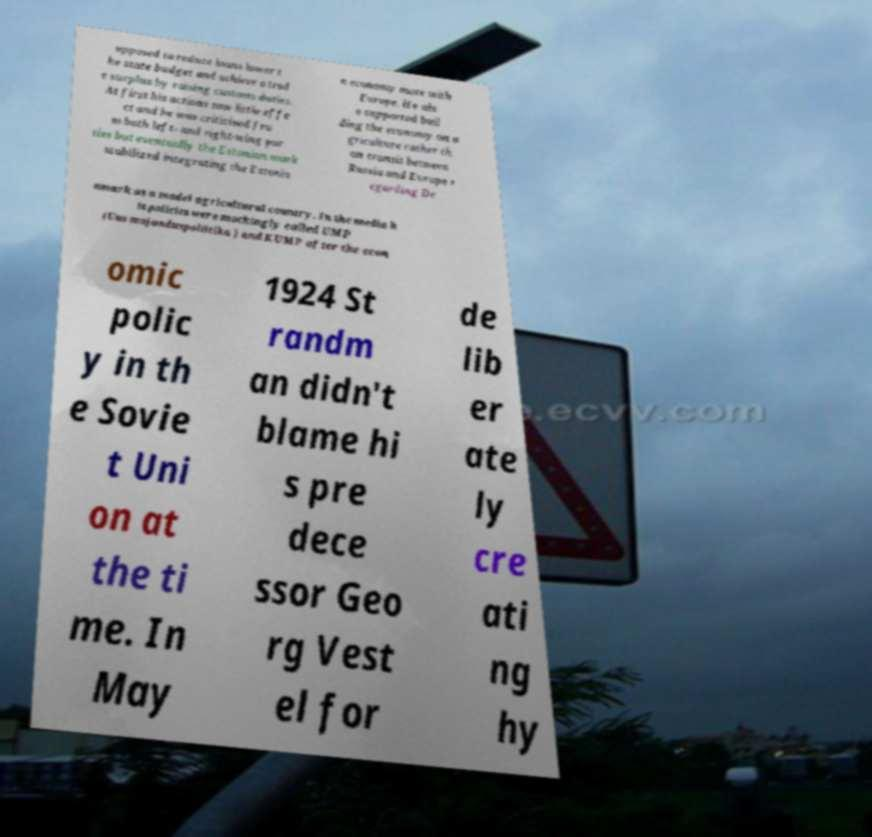I need the written content from this picture converted into text. Can you do that? upposed to reduce loans lower t he state budget and achieve a trad e surplus by raising customs duties. At first his actions saw little effe ct and he was criticised fro m both left- and right-wing par ties but eventually the Estonian mark stabilized integrating the Estonia n economy more with Europe. He als o supported buil ding the economy on a griculture rather th an transit between Russia and Europe r egarding De nmark as a model agricultural country. In the media h is policies were mockingly called UMP (Uus majanduspoliitika ) and KUMP after the econ omic polic y in th e Sovie t Uni on at the ti me. In May 1924 St randm an didn't blame hi s pre dece ssor Geo rg Vest el for de lib er ate ly cre ati ng hy 